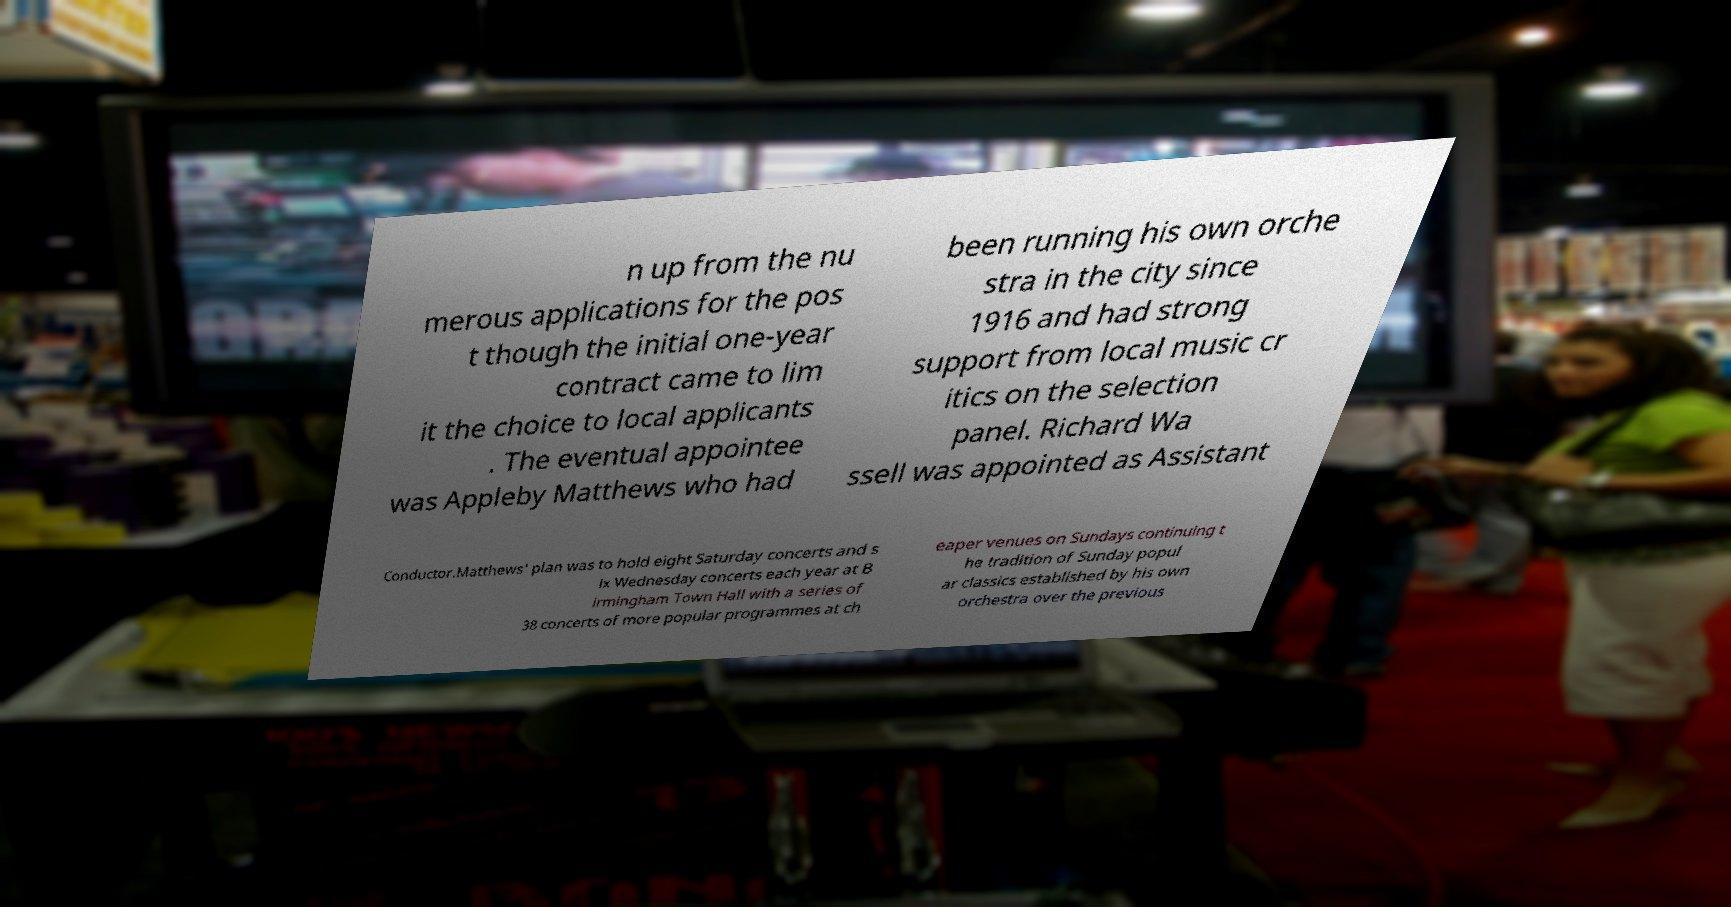I need the written content from this picture converted into text. Can you do that? n up from the nu merous applications for the pos t though the initial one-year contract came to lim it the choice to local applicants . The eventual appointee was Appleby Matthews who had been running his own orche stra in the city since 1916 and had strong support from local music cr itics on the selection panel. Richard Wa ssell was appointed as Assistant Conductor.Matthews' plan was to hold eight Saturday concerts and s ix Wednesday concerts each year at B irmingham Town Hall with a series of 38 concerts of more popular programmes at ch eaper venues on Sundays continuing t he tradition of Sunday popul ar classics established by his own orchestra over the previous 